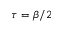Convert formula to latex. <formula><loc_0><loc_0><loc_500><loc_500>\tau = \beta / 2</formula> 